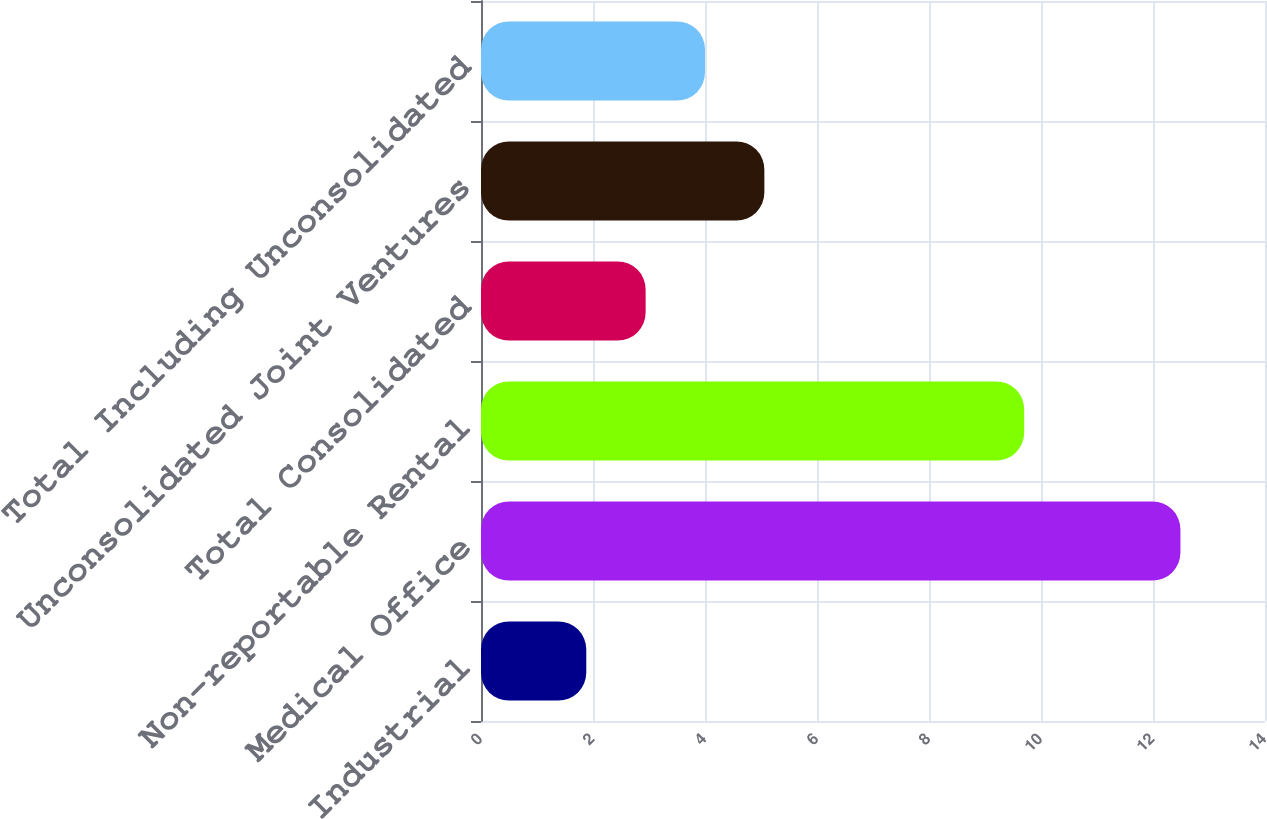Convert chart to OTSL. <chart><loc_0><loc_0><loc_500><loc_500><bar_chart><fcel>Industrial<fcel>Medical Office<fcel>Non-reportable Rental<fcel>Total Consolidated<fcel>Unconsolidated Joint Ventures<fcel>Total Including Unconsolidated<nl><fcel>1.88<fcel>12.49<fcel>9.7<fcel>2.94<fcel>5.06<fcel>4<nl></chart> 